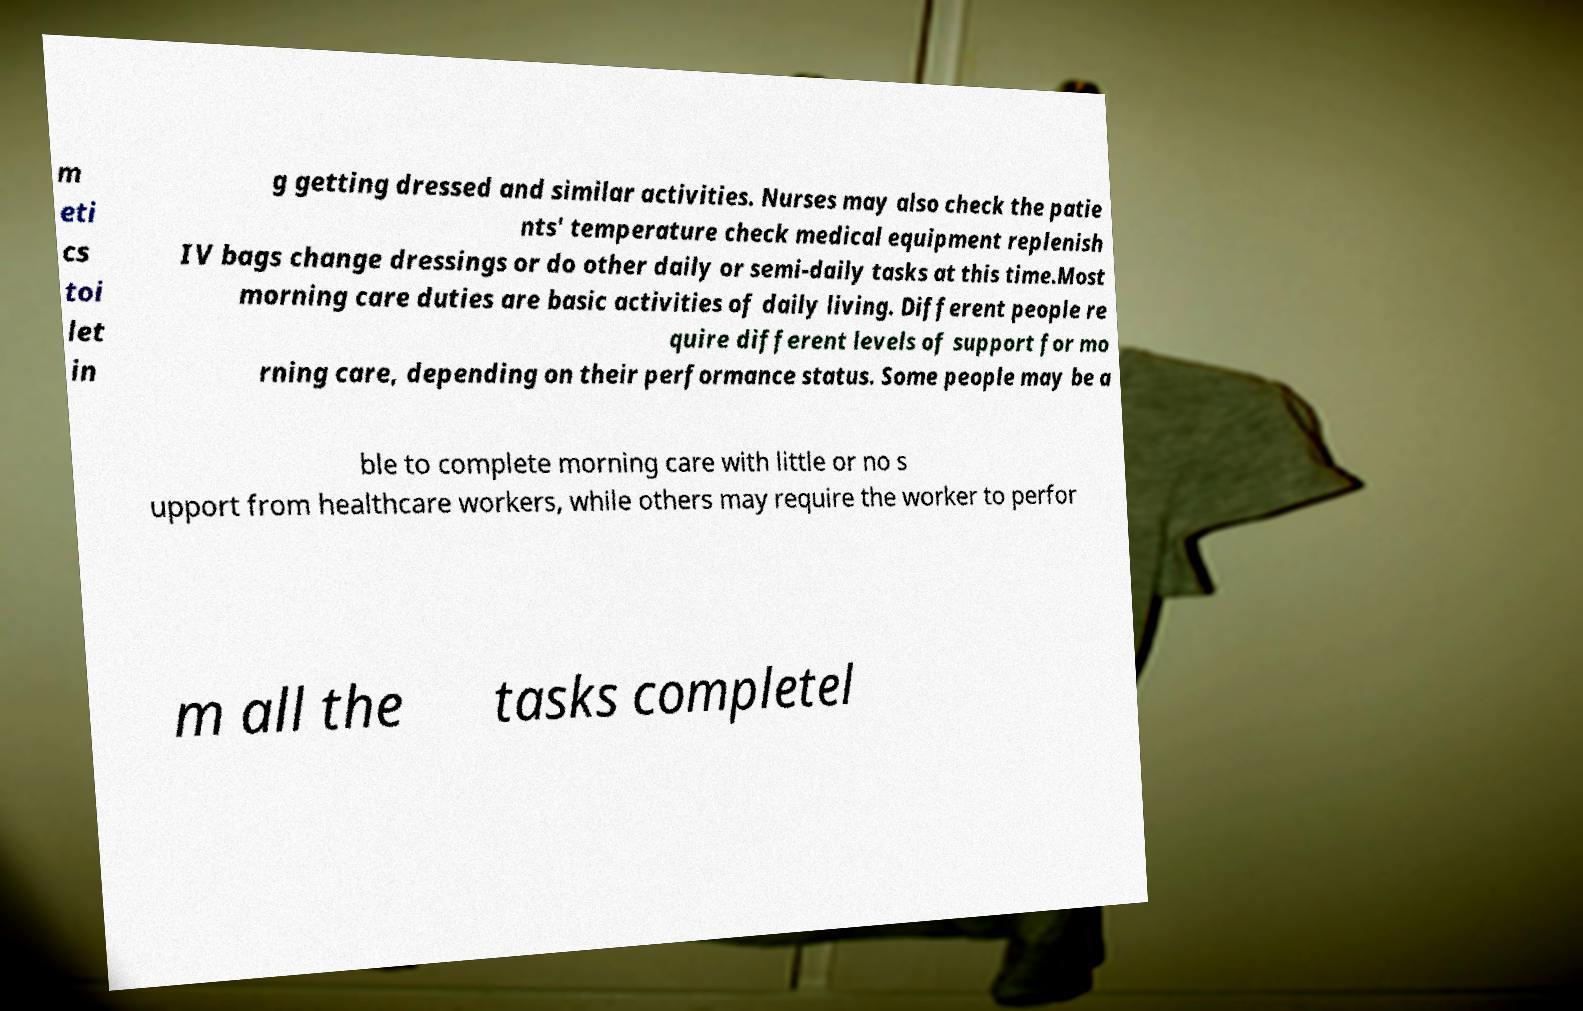For documentation purposes, I need the text within this image transcribed. Could you provide that? m eti cs toi let in g getting dressed and similar activities. Nurses may also check the patie nts' temperature check medical equipment replenish IV bags change dressings or do other daily or semi-daily tasks at this time.Most morning care duties are basic activities of daily living. Different people re quire different levels of support for mo rning care, depending on their performance status. Some people may be a ble to complete morning care with little or no s upport from healthcare workers, while others may require the worker to perfor m all the tasks completel 